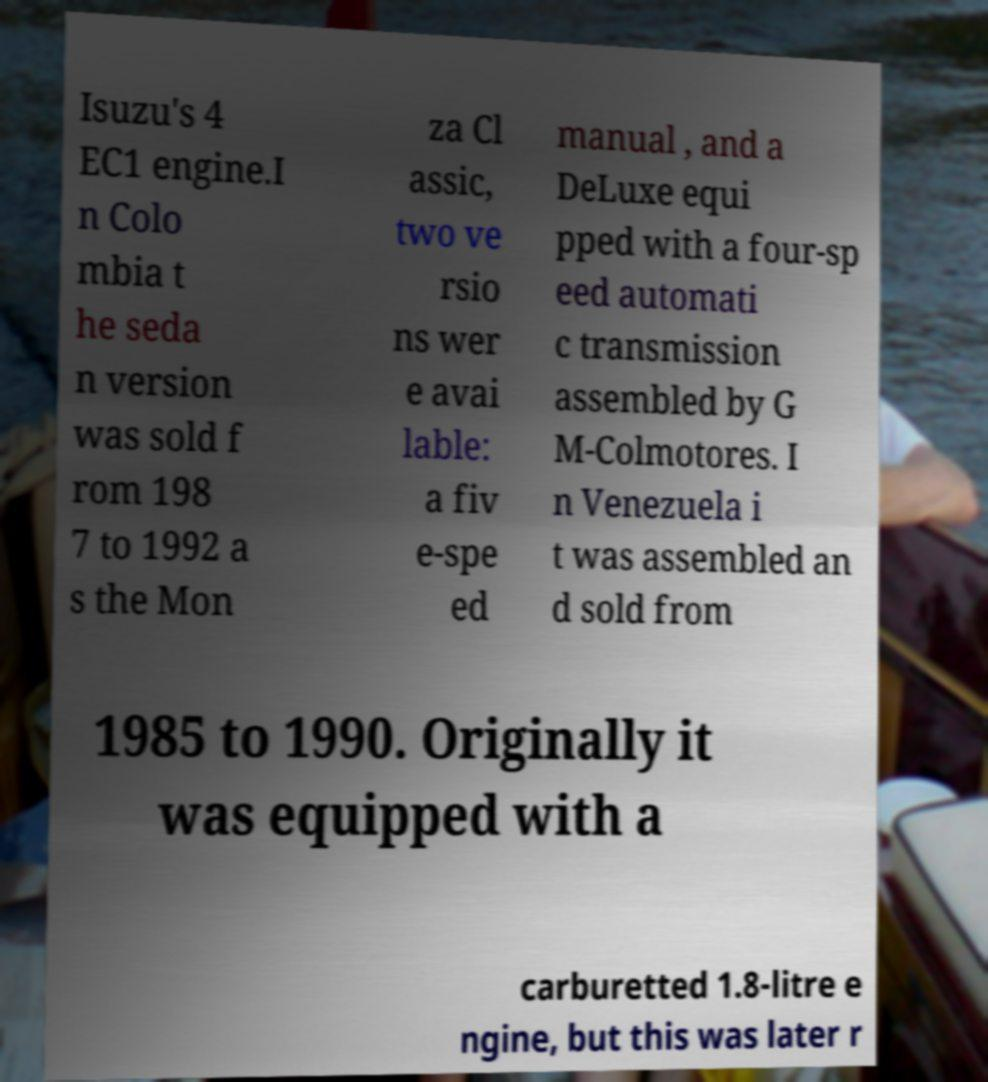Could you assist in decoding the text presented in this image and type it out clearly? Isuzu's 4 EC1 engine.I n Colo mbia t he seda n version was sold f rom 198 7 to 1992 a s the Mon za Cl assic, two ve rsio ns wer e avai lable: a fiv e-spe ed manual , and a DeLuxe equi pped with a four-sp eed automati c transmission assembled by G M-Colmotores. I n Venezuela i t was assembled an d sold from 1985 to 1990. Originally it was equipped with a carburetted 1.8-litre e ngine, but this was later r 